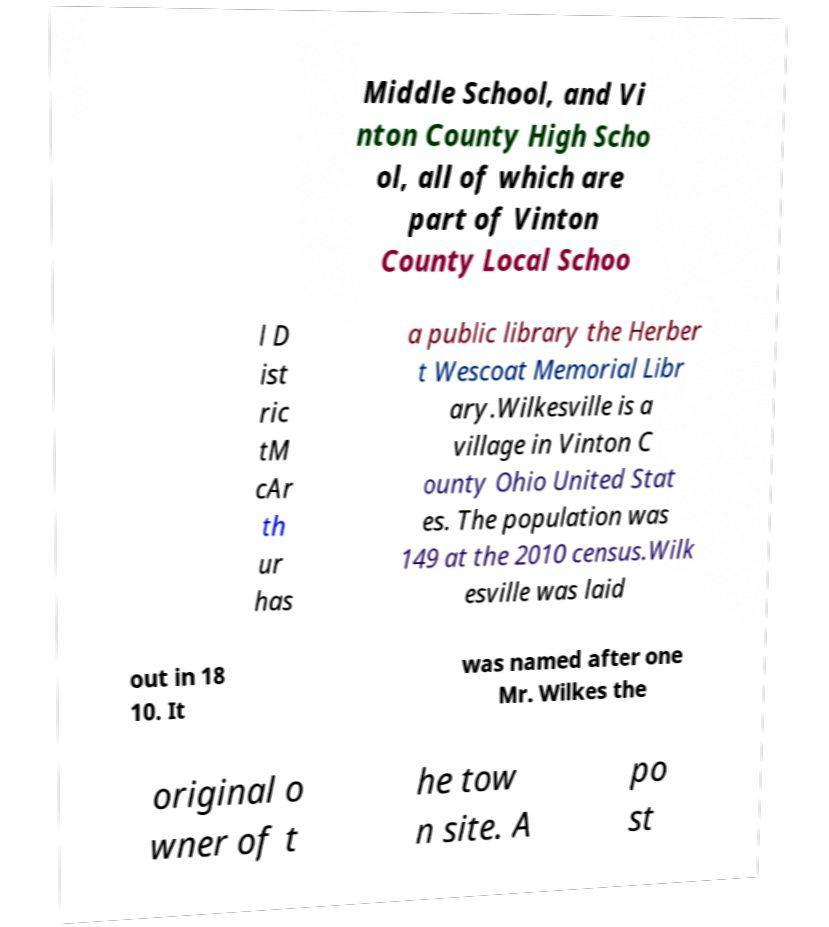Please read and relay the text visible in this image. What does it say? Middle School, and Vi nton County High Scho ol, all of which are part of Vinton County Local Schoo l D ist ric tM cAr th ur has a public library the Herber t Wescoat Memorial Libr ary.Wilkesville is a village in Vinton C ounty Ohio United Stat es. The population was 149 at the 2010 census.Wilk esville was laid out in 18 10. It was named after one Mr. Wilkes the original o wner of t he tow n site. A po st 